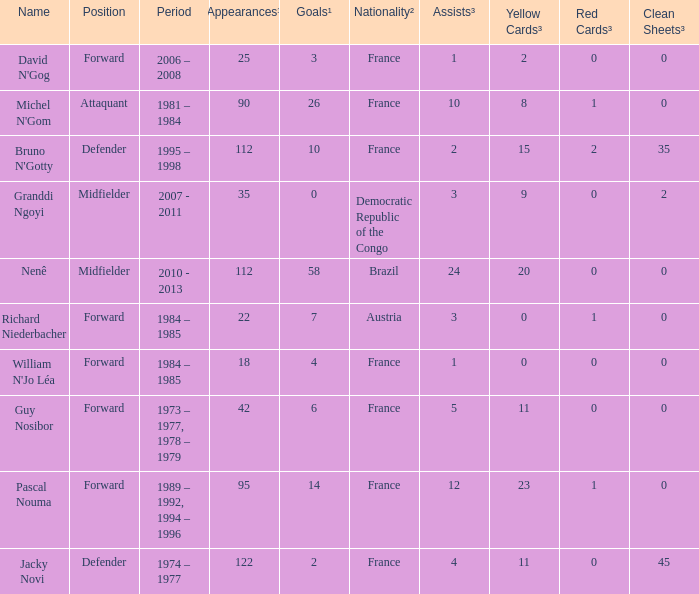List the player that scored 4 times. William N'Jo Léa. 